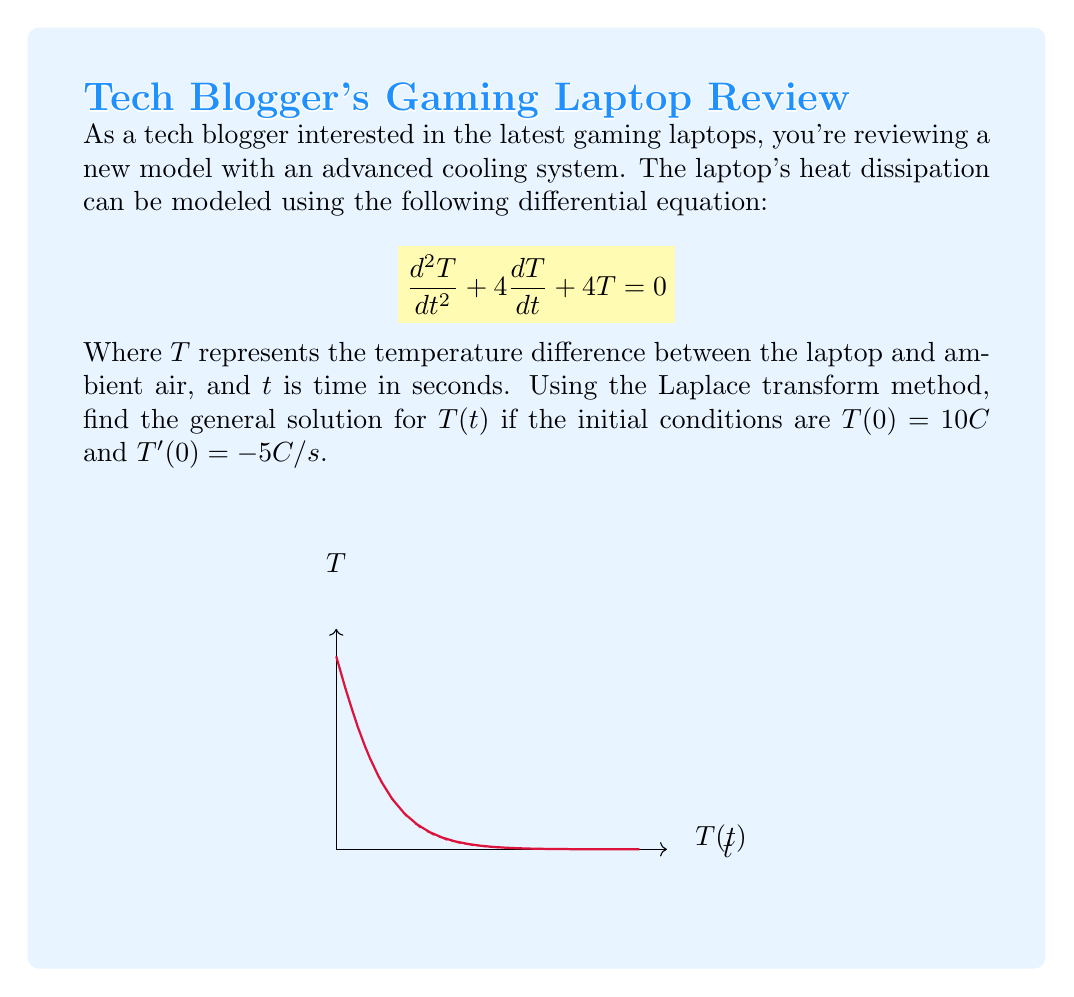Can you solve this math problem? Let's solve this step-by-step using the Laplace transform method:

1) First, we take the Laplace transform of both sides of the equation:
   $$\mathcal{L}\{T''(t)\} + 4\mathcal{L}\{T'(t)\} + 4\mathcal{L}\{T(t)\} = 0$$

2) Using Laplace transform properties:
   $$s^2\mathcal{L}\{T(t)\} - sT(0) - T'(0) + 4s\mathcal{L}\{T(t)\} - 4T(0) + 4\mathcal{L}\{T(t)\} = 0$$

3) Let $\mathcal{L}\{T(t)\} = X(s)$. Substituting the initial conditions:
   $$s^2X(s) - 10s + 5 + 4sX(s) - 40 + 4X(s) = 0$$

4) Simplify:
   $$(s^2 + 4s + 4)X(s) = 10s + 35$$

5) Solve for $X(s)$:
   $$X(s) = \frac{10s + 35}{s^2 + 4s + 4} = \frac{10s + 35}{(s+2)^2}$$

6) Decompose into partial fractions:
   $$X(s) = \frac{A}{s+2} + \frac{B}{(s+2)^2}$$

   Where $A = 10$ and $B = 15$

7) Take the inverse Laplace transform:
   $$T(t) = \mathcal{L}^{-1}\{X(s)\} = 10e^{-2t} + 15te^{-2t}$$

This is the general solution for $T(t)$.
Answer: $T(t) = 10e^{-2t} + 15te^{-2t}$ 